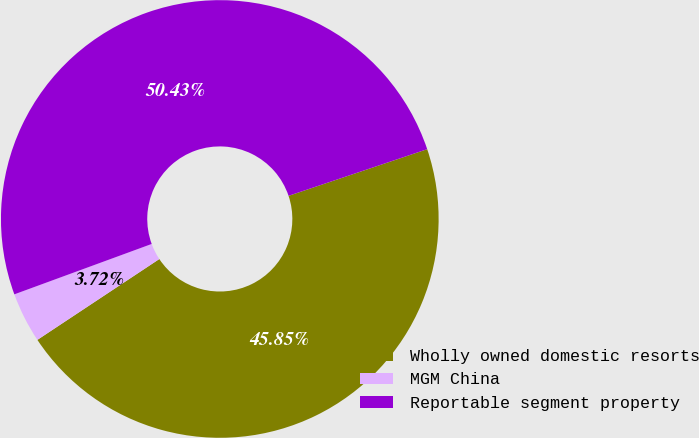<chart> <loc_0><loc_0><loc_500><loc_500><pie_chart><fcel>Wholly owned domestic resorts<fcel>MGM China<fcel>Reportable segment property<nl><fcel>45.85%<fcel>3.72%<fcel>50.43%<nl></chart> 